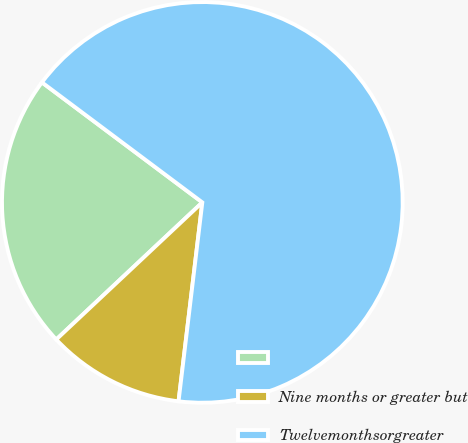Convert chart to OTSL. <chart><loc_0><loc_0><loc_500><loc_500><pie_chart><ecel><fcel>Nine months or greater but<fcel>Twelvemonthsorgreater<nl><fcel>22.22%<fcel>11.11%<fcel>66.67%<nl></chart> 